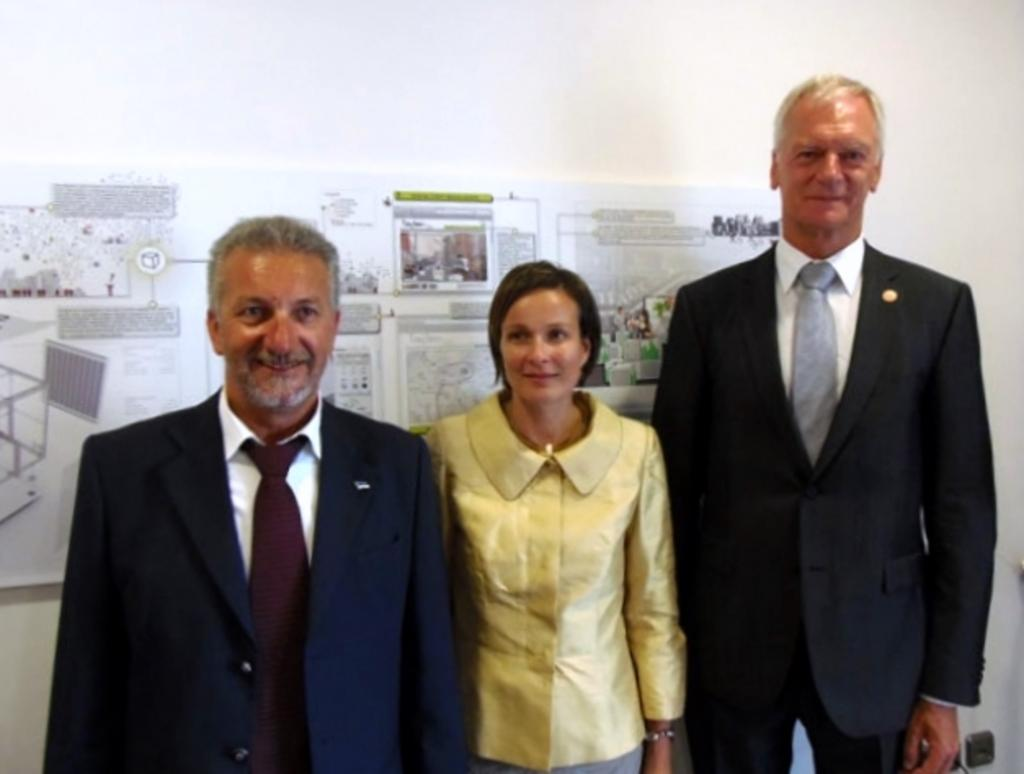How many people are present in the image? There are three people in the image. What is the facial expression of the people in the image? The people are smiling. What is the people standing on in the image? The people are standing on a surface. What can be seen on the wall in the image? There are charts on the wall in the image. What type of creature is depicted on the canvas in the image? There is no canvas or creature present in the image. 